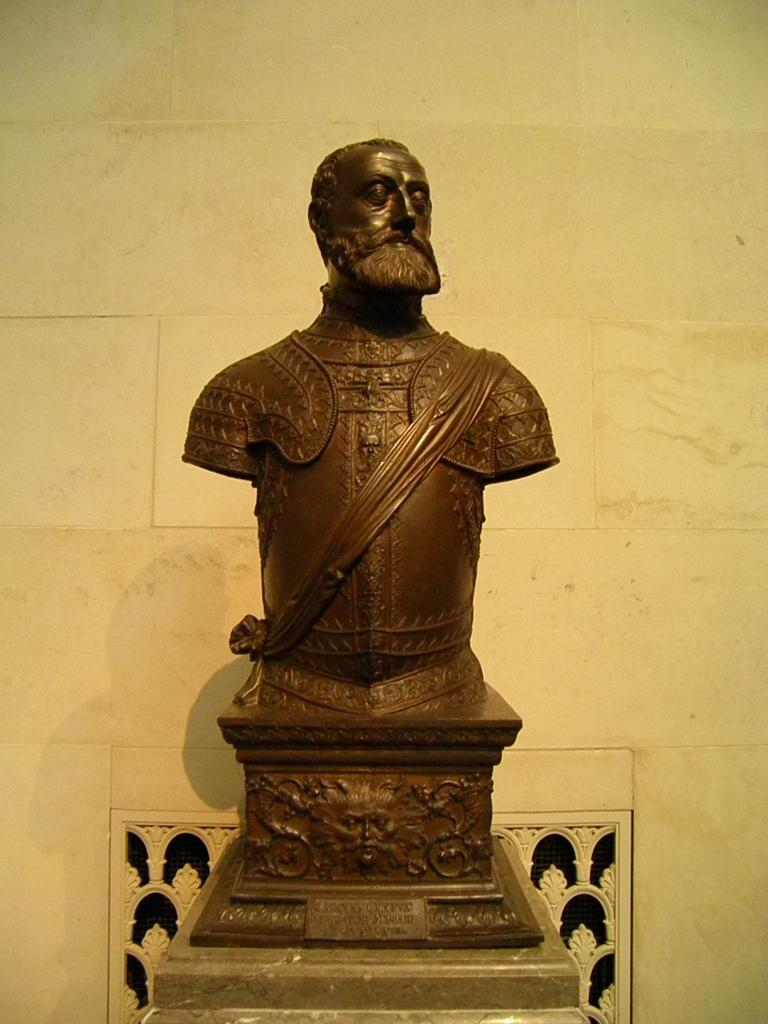What is the main subject of the image? There is a statue of a person in the image. What material is the statue made from? The statue is made from steel or iron. What can be seen in the background of the image? There is a wall visible in the background of the image. What type of suit is the kitten wearing in the image? There is no kitten or suit present in the image. How many bananas are being held by the statue in the image? There are no bananas visible in the image; the statue is made of steel or iron and does not hold any objects. 